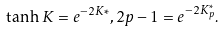Convert formula to latex. <formula><loc_0><loc_0><loc_500><loc_500>\tanh K = e ^ { - 2 K { * } } , 2 p - 1 = e ^ { - 2 K _ { p } ^ { * } } .</formula> 